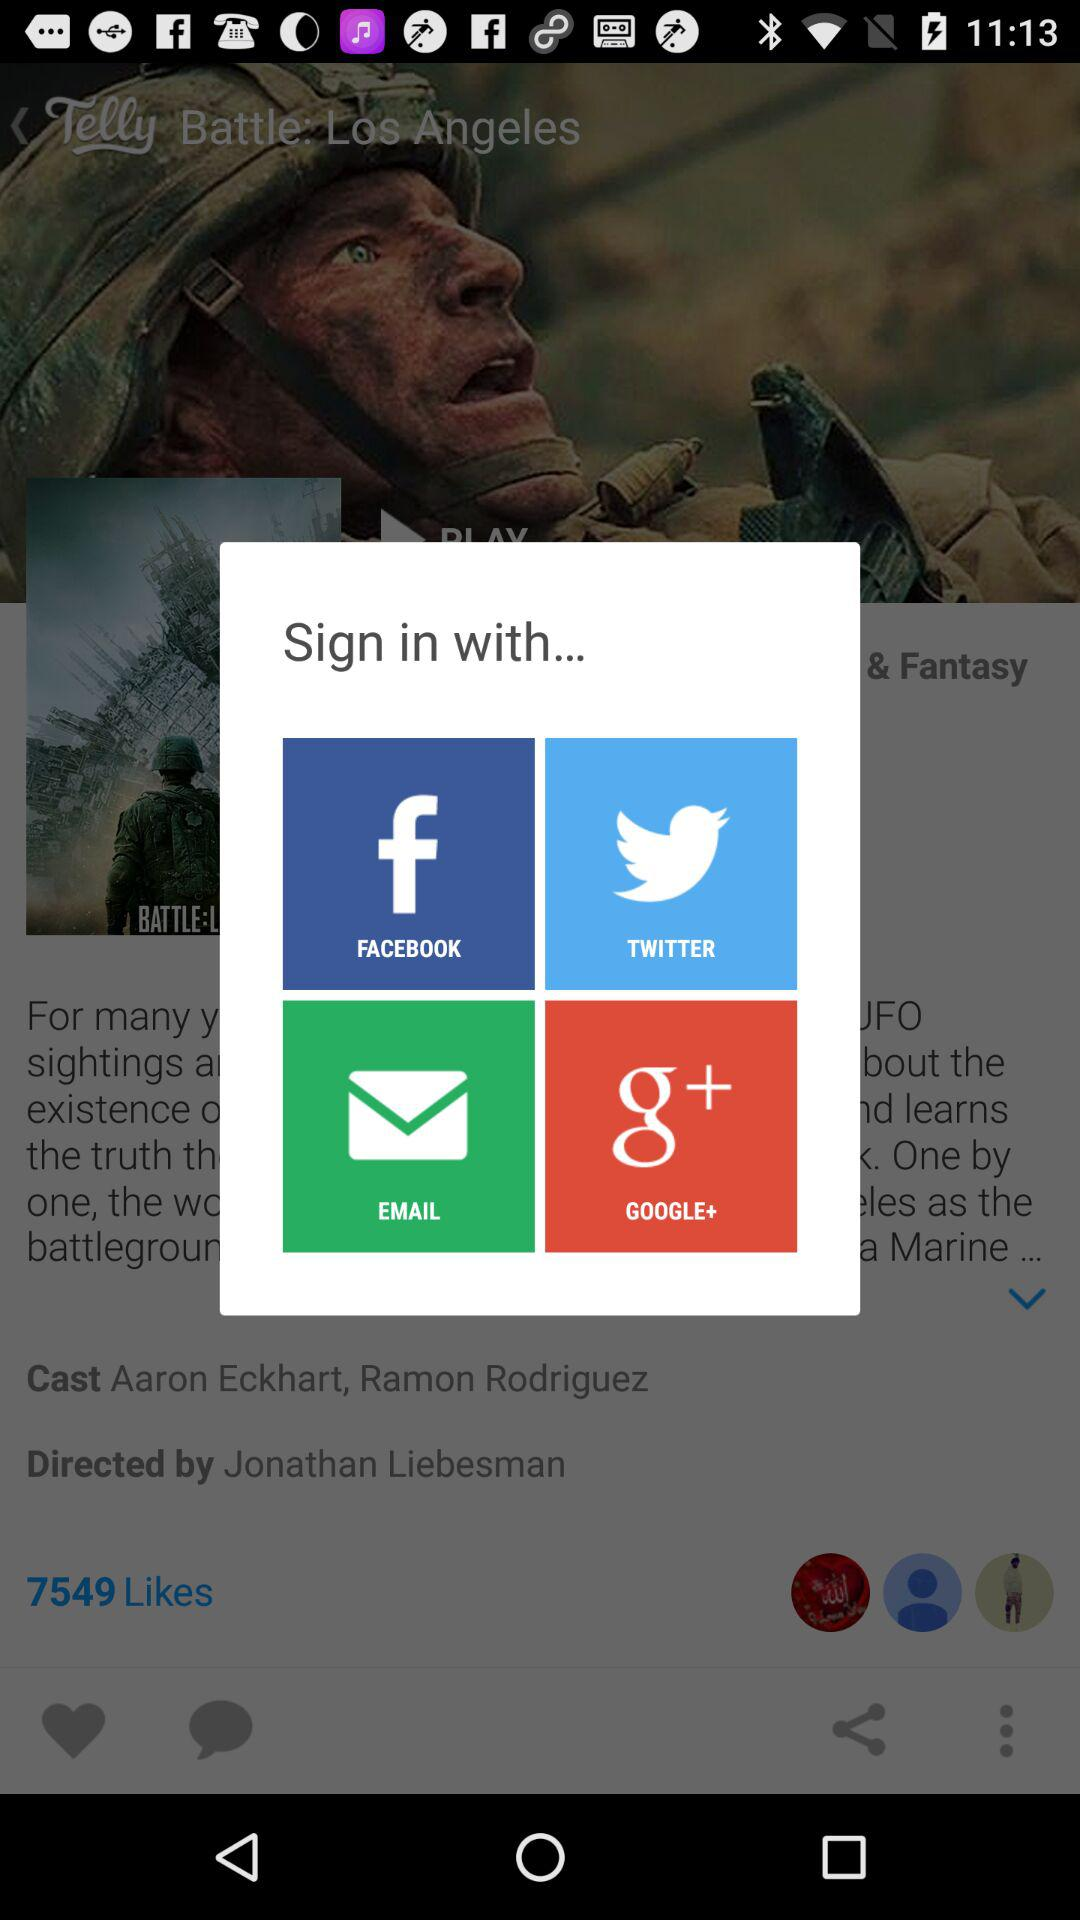How many sign in options are there?
Answer the question using a single word or phrase. 4 